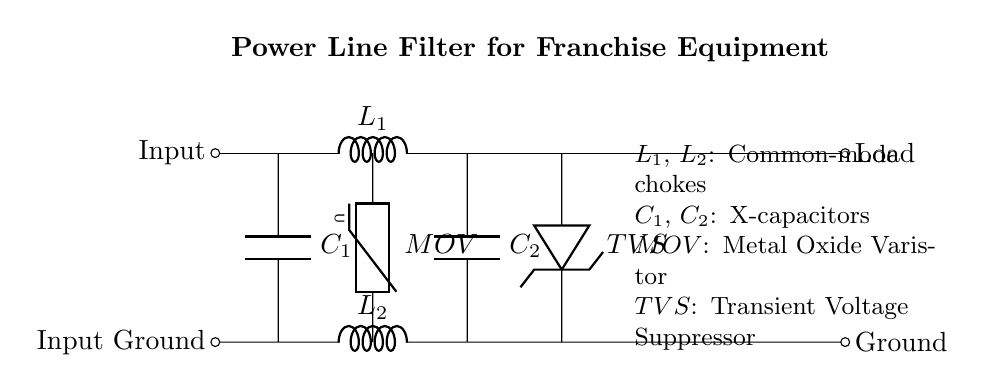What are the components labeled L1 and L2? The components labeled L1 and L2 are both common-mode chokes, which are used to filter out unwanted noise in the circuit. They appear as two inductors in the diagram.
Answer: common-mode chokes What does MOV stand for? MOV stands for Metal Oxide Varistor, which is a protective component that absorbs voltage spikes and protects equipment from transient voltages. It is located in the circuit between the two lines.
Answer: Metal Oxide Varistor How many capacitors are present in the circuit? There are two capacitors present in the circuit, labeled C1 and C2. They are used for filtering out high-frequency noise.
Answer: 2 What is the purpose of the TVS diode? The purpose of the TVS diode, labeled as TVS in the circuit, is to protect the circuit by clamping voltage spikes to safe levels, thereby preventing damage to sensitive equipment.
Answer: voltage spike protection Which components are connected in parallel? The capacitors C1 and C2 are connected in parallel to each other, as well as the MOV and TVS diode. In parallel configuration, the voltage across each component is the same.
Answer: C1, C2, MOV, TVS What is the significance of the input and input ground labels? The input label indicates where the power supply connects to the filter circuit for powering the load, while the input ground label indicates the return path or reference point for the circuit, critical for safety and stability in operation.
Answer: power supply connection What type of filter is represented in this diagram? The circuit represents a power line filter, specifically designed to protect equipment from voltage fluctuations and noise commonly found in power lines, ensuring stable operation of sensitive devices.
Answer: power line filter 